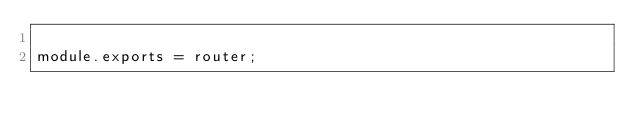Convert code to text. <code><loc_0><loc_0><loc_500><loc_500><_JavaScript_>
module.exports = router;
</code> 